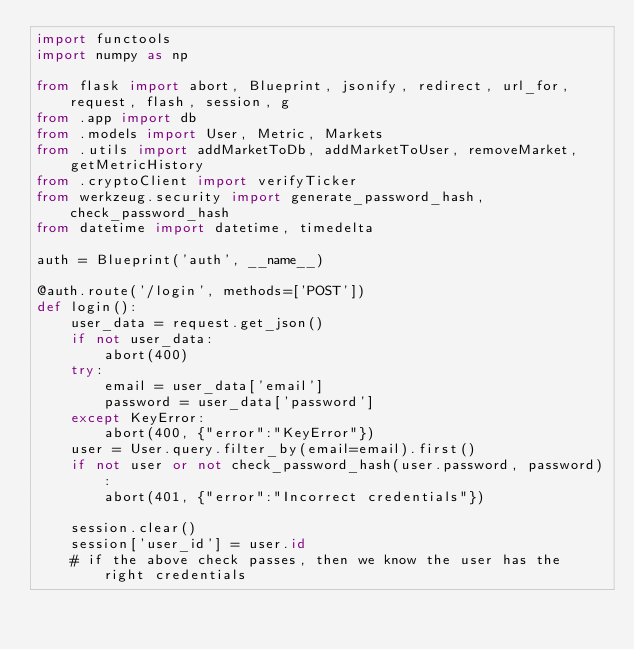Convert code to text. <code><loc_0><loc_0><loc_500><loc_500><_Python_>import functools
import numpy as np

from flask import abort, Blueprint, jsonify, redirect, url_for, request, flash, session, g
from .app import db 
from .models import User, Metric, Markets
from .utils import addMarketToDb, addMarketToUser, removeMarket, getMetricHistory
from .cryptoClient import verifyTicker
from werkzeug.security import generate_password_hash, check_password_hash
from datetime import datetime, timedelta

auth = Blueprint('auth', __name__)

@auth.route('/login', methods=['POST'])
def login():
    user_data = request.get_json()
    if not user_data:
        abort(400)
    try:
        email = user_data['email']
        password = user_data['password']
    except KeyError:
        abort(400, {"error":"KeyError"})
    user = User.query.filter_by(email=email).first()
    if not user or not check_password_hash(user.password, password):
        abort(401, {"error":"Incorrect credentials"})

    session.clear()
    session['user_id'] = user.id 
    # if the above check passes, then we know the user has the right credentials</code> 